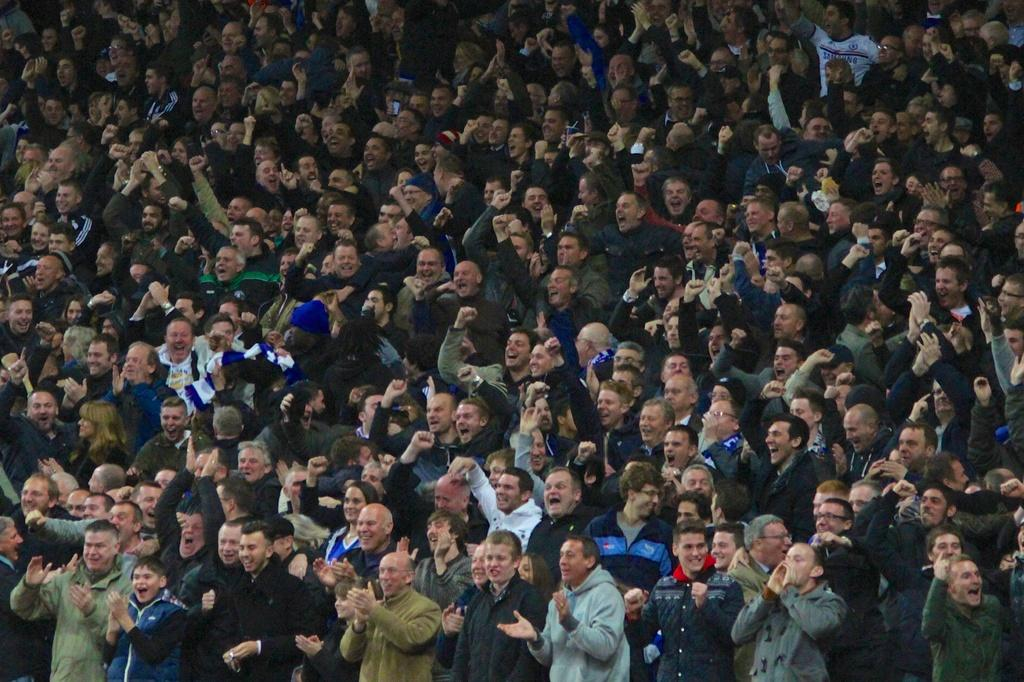What is the main subject in the foreground of the image? There is a crowd in the foreground of the image. What is the crowd doing in the image? The crowd is cheering. What type of fuel is being used by the crowd in the image? There is no mention of fuel in the image, as the crowd is cheering and not using any fuel. 